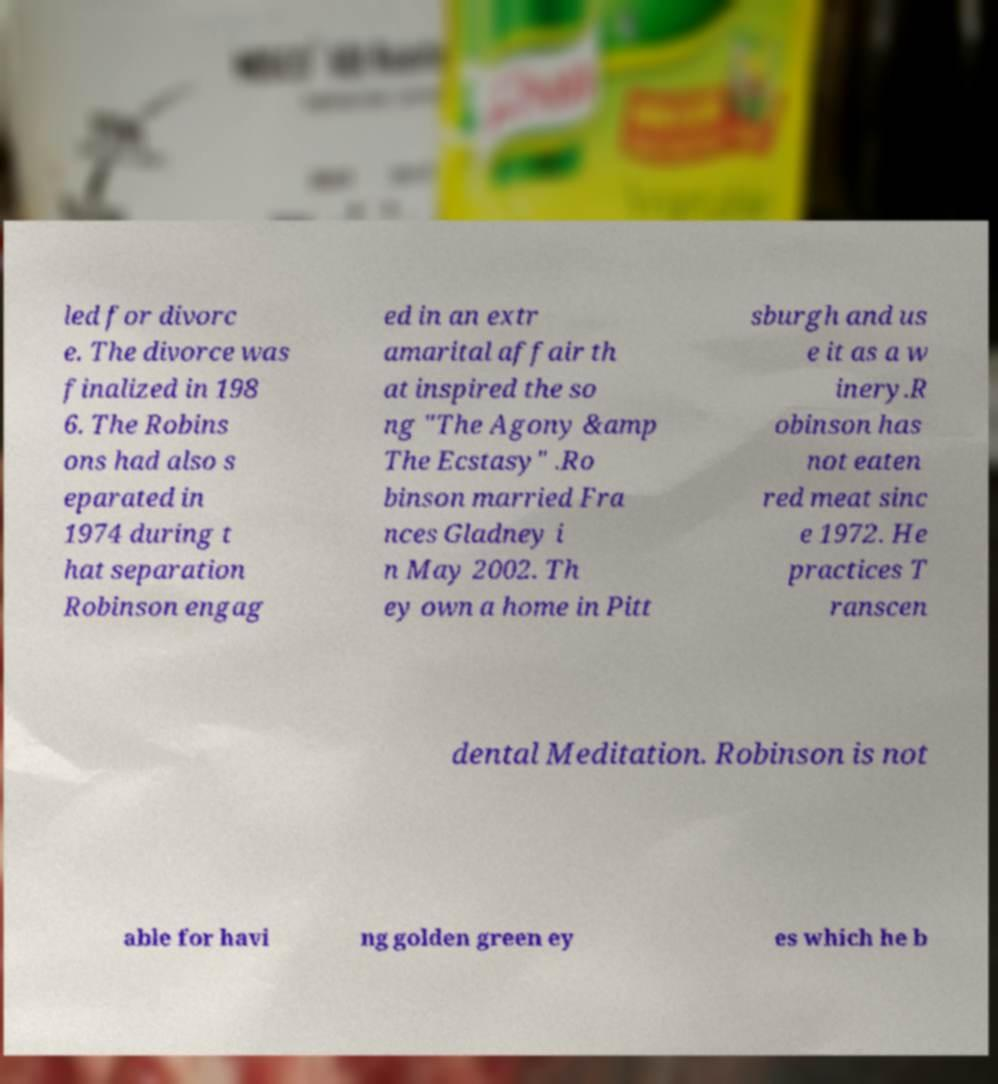Please identify and transcribe the text found in this image. led for divorc e. The divorce was finalized in 198 6. The Robins ons had also s eparated in 1974 during t hat separation Robinson engag ed in an extr amarital affair th at inspired the so ng "The Agony &amp The Ecstasy" .Ro binson married Fra nces Gladney i n May 2002. Th ey own a home in Pitt sburgh and us e it as a w inery.R obinson has not eaten red meat sinc e 1972. He practices T ranscen dental Meditation. Robinson is not able for havi ng golden green ey es which he b 